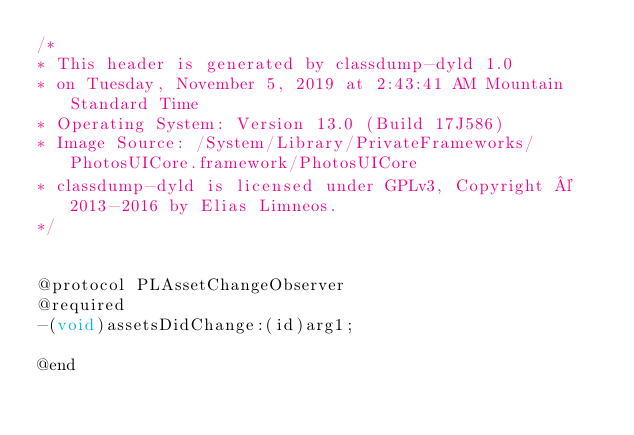Convert code to text. <code><loc_0><loc_0><loc_500><loc_500><_C_>/*
* This header is generated by classdump-dyld 1.0
* on Tuesday, November 5, 2019 at 2:43:41 AM Mountain Standard Time
* Operating System: Version 13.0 (Build 17J586)
* Image Source: /System/Library/PrivateFrameworks/PhotosUICore.framework/PhotosUICore
* classdump-dyld is licensed under GPLv3, Copyright © 2013-2016 by Elias Limneos.
*/


@protocol PLAssetChangeObserver
@required
-(void)assetsDidChange:(id)arg1;

@end

</code> 